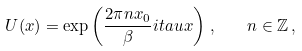Convert formula to latex. <formula><loc_0><loc_0><loc_500><loc_500>U ( x ) = \exp \left ( \frac { 2 \pi n x _ { 0 } } { \beta } i t a u x \right ) \, , \quad n \in { \mathbb { Z } } \, ,</formula> 